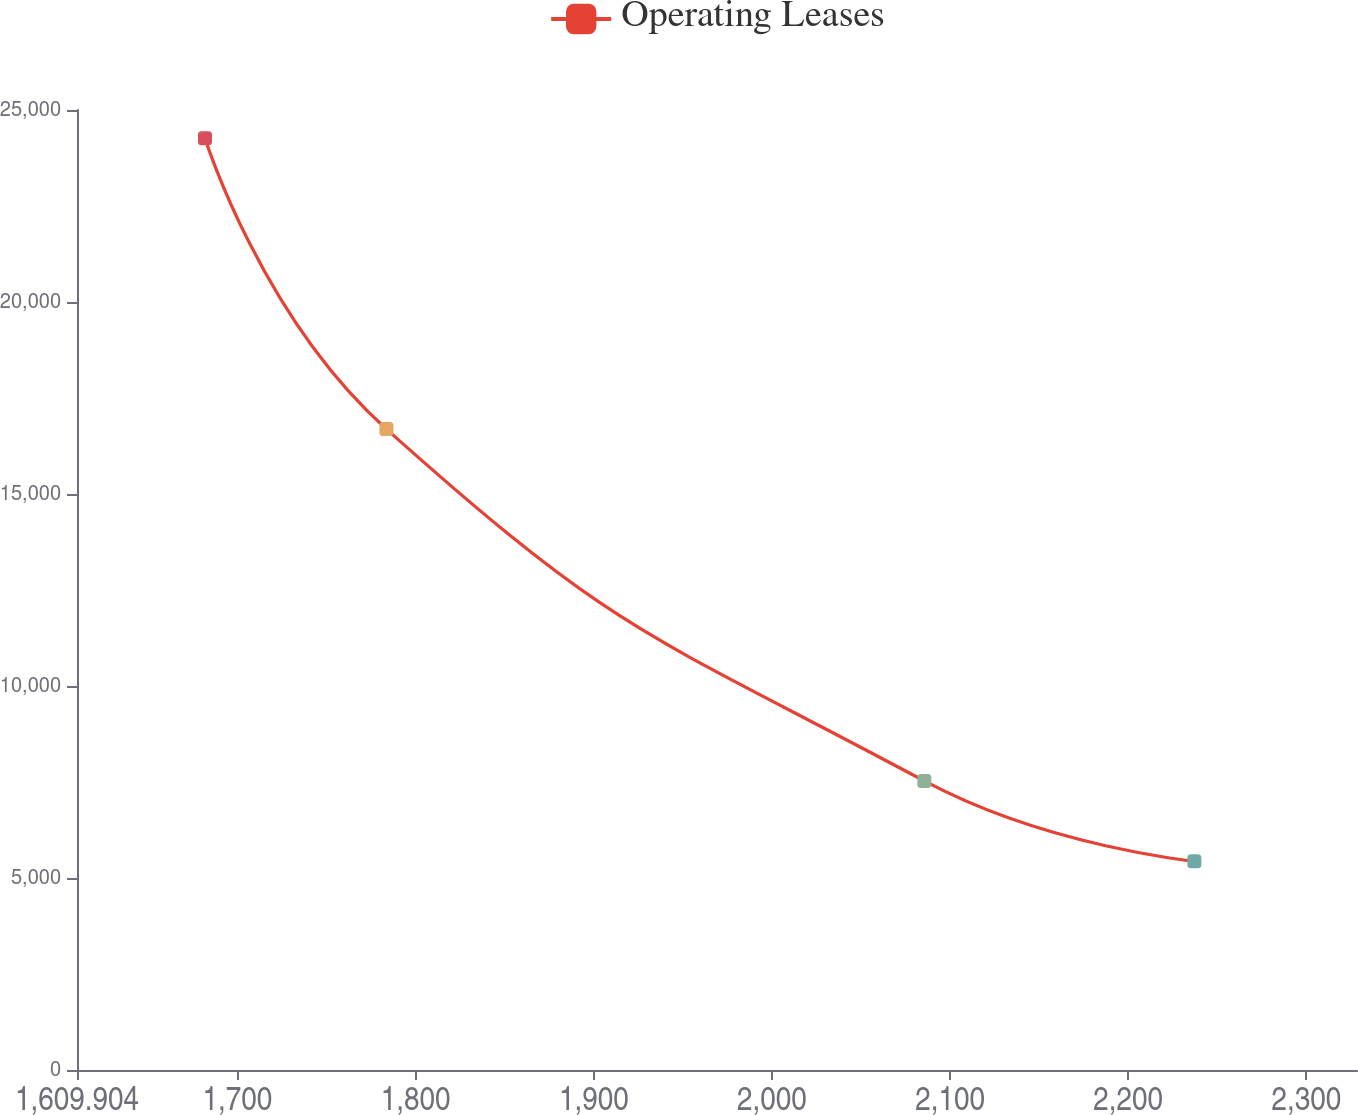Convert chart. <chart><loc_0><loc_0><loc_500><loc_500><line_chart><ecel><fcel>Operating Leases<nl><fcel>1681.76<fcel>24261.9<nl><fcel>1783.62<fcel>16690.7<nl><fcel>2085.57<fcel>7527.27<nl><fcel>2237.17<fcel>5435.44<nl><fcel>2400.32<fcel>3343.61<nl></chart> 